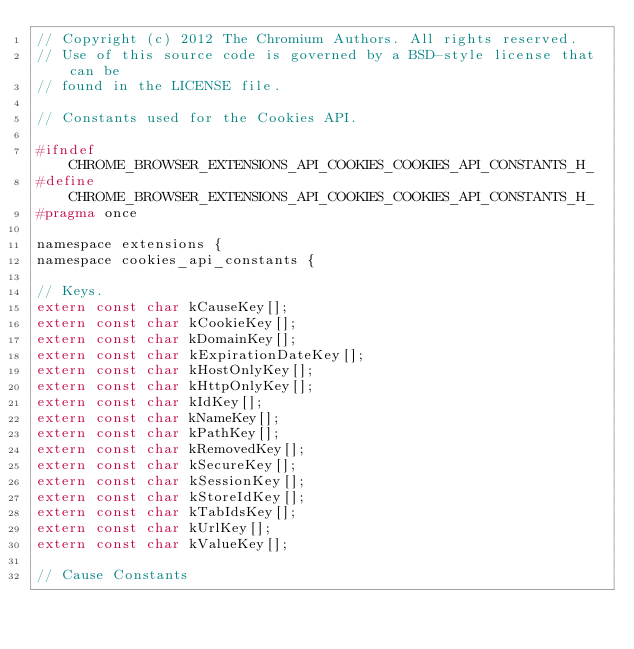Convert code to text. <code><loc_0><loc_0><loc_500><loc_500><_C_>// Copyright (c) 2012 The Chromium Authors. All rights reserved.
// Use of this source code is governed by a BSD-style license that can be
// found in the LICENSE file.

// Constants used for the Cookies API.

#ifndef CHROME_BROWSER_EXTENSIONS_API_COOKIES_COOKIES_API_CONSTANTS_H_
#define CHROME_BROWSER_EXTENSIONS_API_COOKIES_COOKIES_API_CONSTANTS_H_
#pragma once

namespace extensions {
namespace cookies_api_constants {

// Keys.
extern const char kCauseKey[];
extern const char kCookieKey[];
extern const char kDomainKey[];
extern const char kExpirationDateKey[];
extern const char kHostOnlyKey[];
extern const char kHttpOnlyKey[];
extern const char kIdKey[];
extern const char kNameKey[];
extern const char kPathKey[];
extern const char kRemovedKey[];
extern const char kSecureKey[];
extern const char kSessionKey[];
extern const char kStoreIdKey[];
extern const char kTabIdsKey[];
extern const char kUrlKey[];
extern const char kValueKey[];

// Cause Constants</code> 